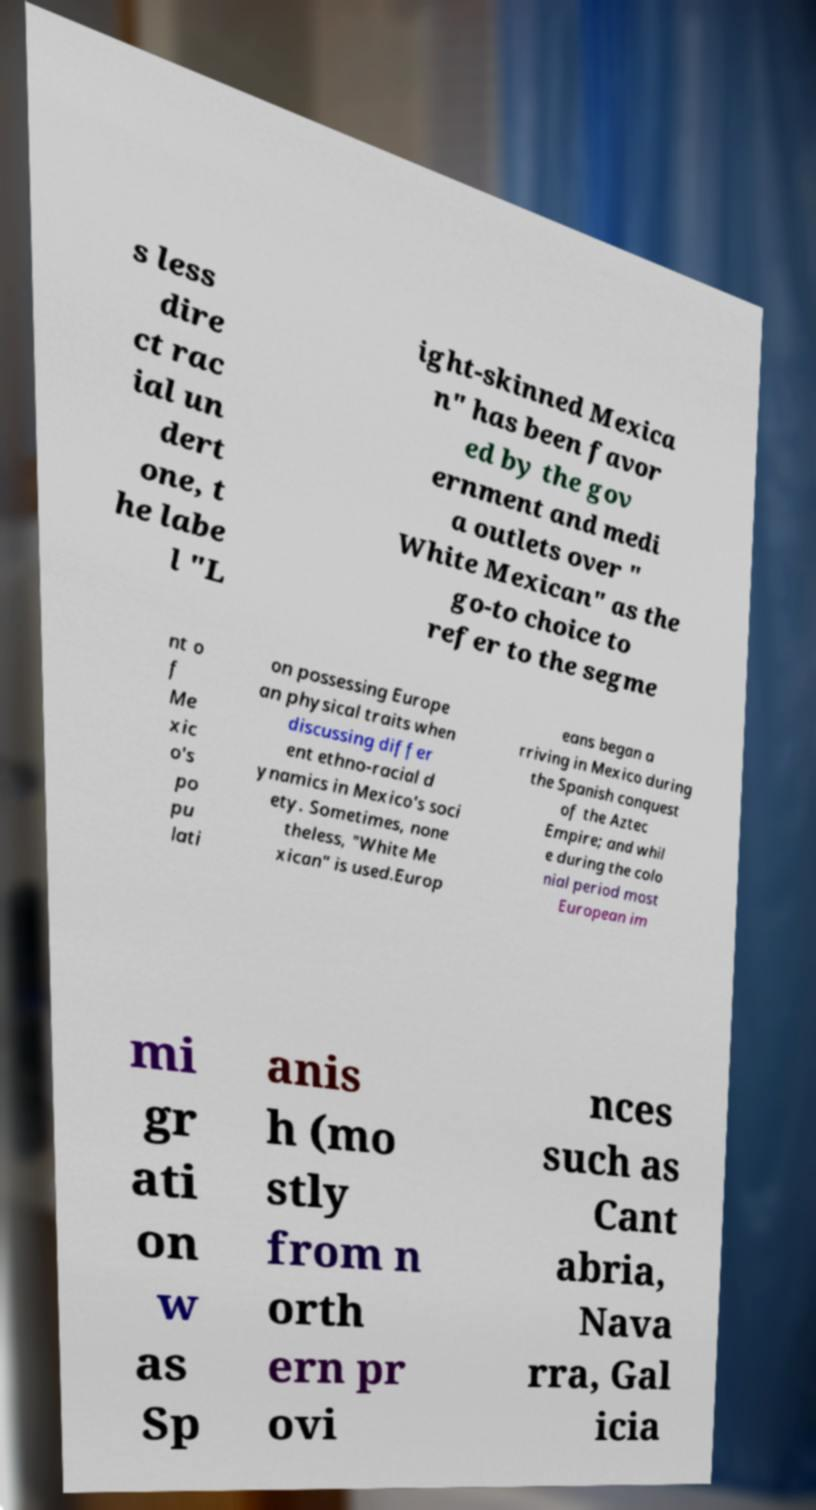Please identify and transcribe the text found in this image. s less dire ct rac ial un dert one, t he labe l "L ight-skinned Mexica n" has been favor ed by the gov ernment and medi a outlets over " White Mexican" as the go-to choice to refer to the segme nt o f Me xic o's po pu lati on possessing Europe an physical traits when discussing differ ent ethno-racial d ynamics in Mexico's soci ety. Sometimes, none theless, "White Me xican" is used.Europ eans began a rriving in Mexico during the Spanish conquest of the Aztec Empire; and whil e during the colo nial period most European im mi gr ati on w as Sp anis h (mo stly from n orth ern pr ovi nces such as Cant abria, Nava rra, Gal icia 